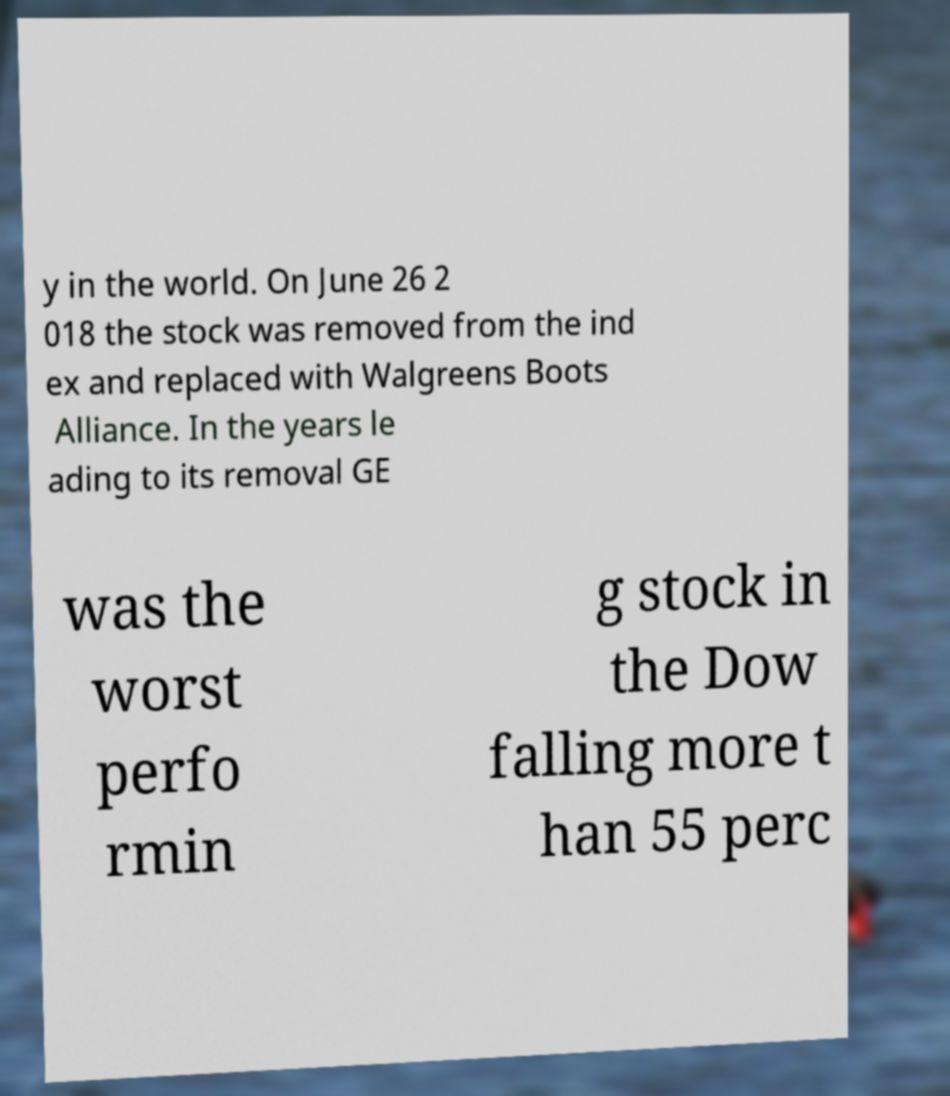Can you read and provide the text displayed in the image?This photo seems to have some interesting text. Can you extract and type it out for me? y in the world. On June 26 2 018 the stock was removed from the ind ex and replaced with Walgreens Boots Alliance. In the years le ading to its removal GE was the worst perfo rmin g stock in the Dow falling more t han 55 perc 